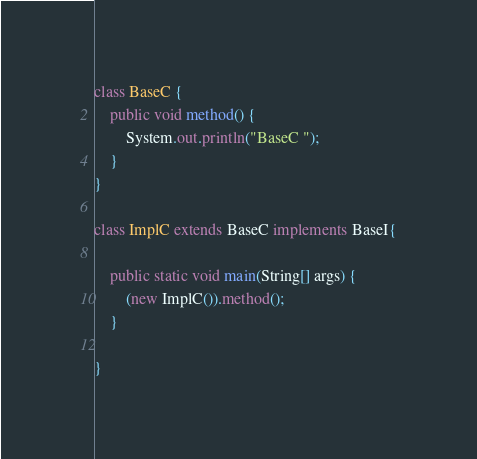<code> <loc_0><loc_0><loc_500><loc_500><_Java_>class BaseC {
    public void method() {
        System.out.println("BaseC ");
    }
}

class ImplC extends BaseC implements BaseI{

    public static void main(String[] args) {
        (new ImplC()).method();
    }

}
</code> 